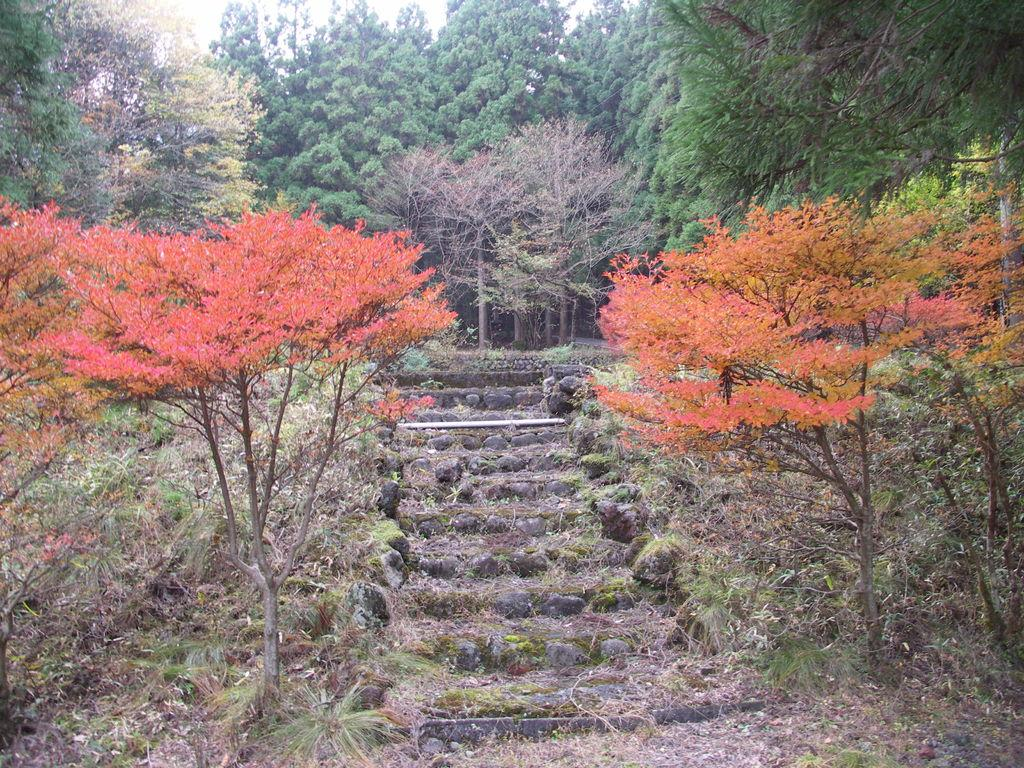What type of vegetation can be seen in the image? There are trees in the image, spanning from left to right. What other elements can be seen on the ground in the image? There are stones visible in the image. What type of ground cover is present in the image? Grass is present on the ground in the image. What type of corn can be seen growing in the image? There is no corn present in the image; it features trees, stones, and grass. How does the wind affect the trees in the image? The image does not show any wind or its effects on the trees; it only shows the trees' static appearance. 